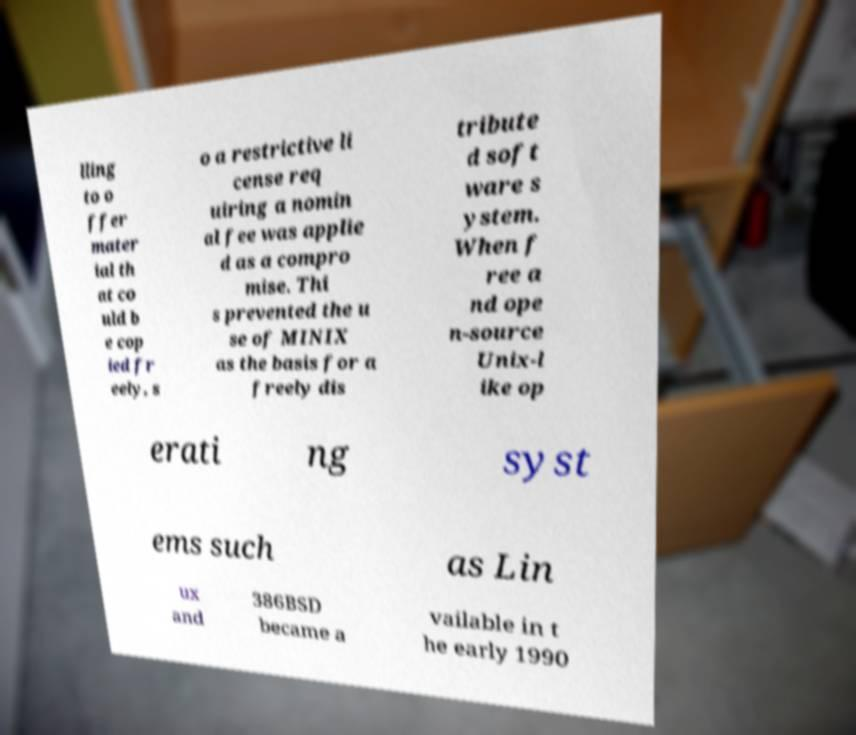Could you assist in decoding the text presented in this image and type it out clearly? lling to o ffer mater ial th at co uld b e cop ied fr eely, s o a restrictive li cense req uiring a nomin al fee was applie d as a compro mise. Thi s prevented the u se of MINIX as the basis for a freely dis tribute d soft ware s ystem. When f ree a nd ope n-source Unix-l ike op erati ng syst ems such as Lin ux and 386BSD became a vailable in t he early 1990 